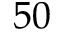<formula> <loc_0><loc_0><loc_500><loc_500>5 0</formula> 